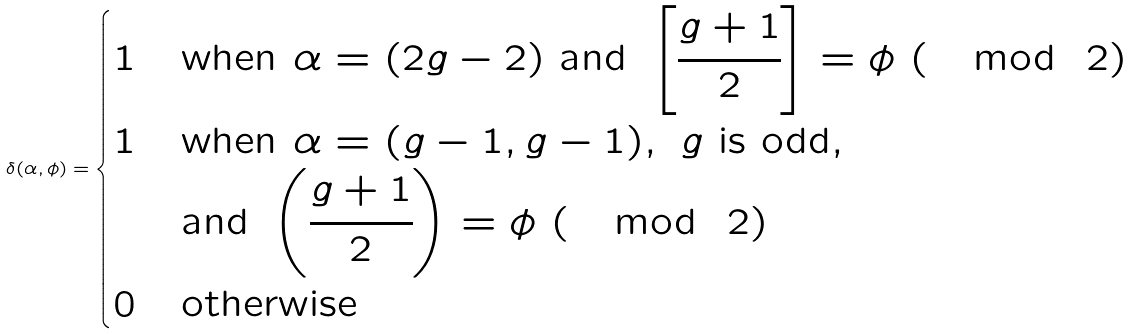<formula> <loc_0><loc_0><loc_500><loc_500>\delta ( \alpha , \phi ) = \begin{cases} 1 & \text {when } \alpha = ( 2 g - 2 ) \text { and } \left [ \cfrac { g + 1 } { 2 } \right ] = \phi \ ( \mod \ 2 ) \\ 1 & \text {when } \alpha = ( g - 1 , g - 1 ) , \ g \text { is odd} , \\ & \text {and } \left ( \cfrac { g + 1 } { 2 } \right ) = \phi \ ( \mod \ 2 ) \\ 0 & \text {otherwise} \end{cases}</formula> 